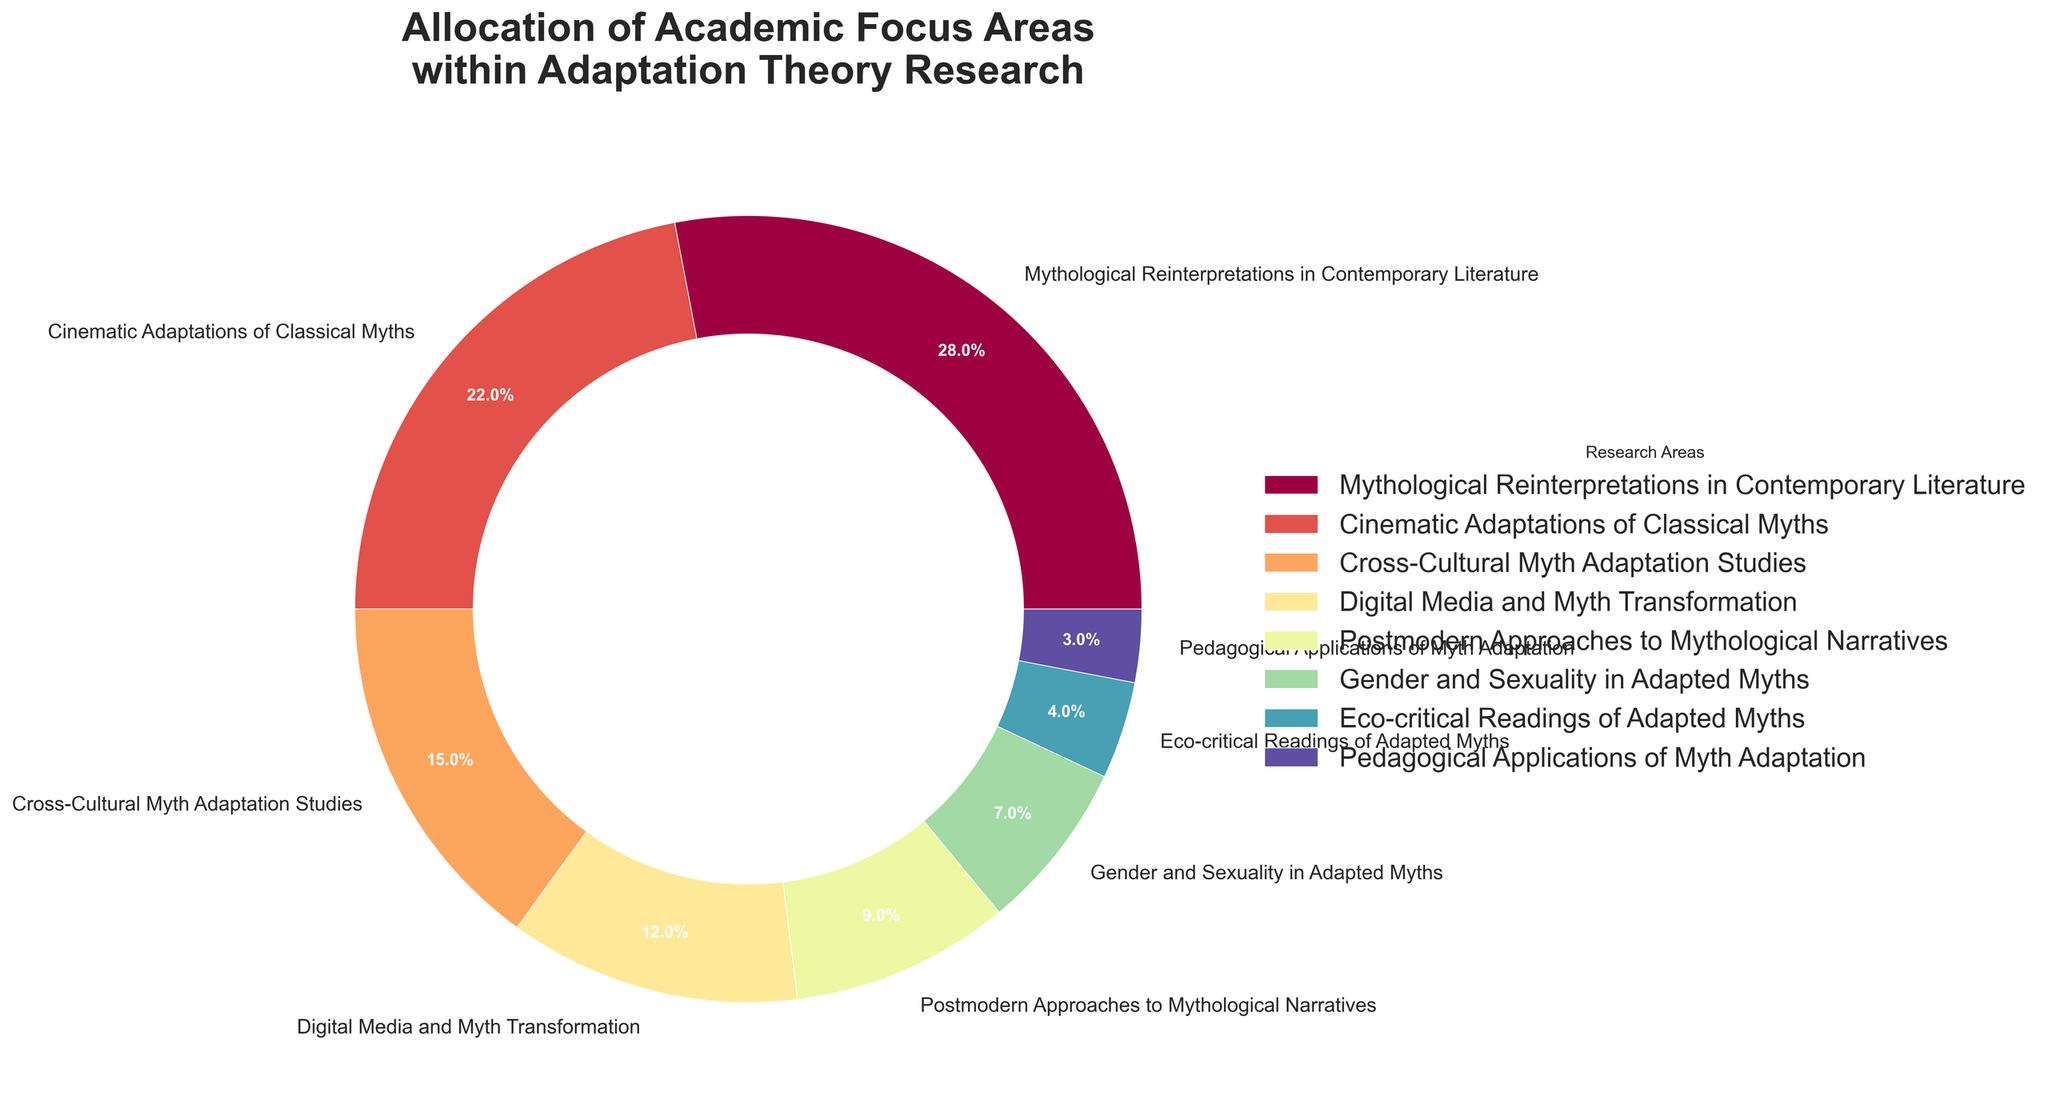What's the most researched area in this pie chart? To find the most researched area, look for the segment with the largest percentage. The "Mythological Reinterpretations in Contemporary Literature" segment has the largest size, which is 28%.
Answer: Mythological Reinterpretations in Contemporary Literature How does the percentage allocated to "Cinematic Adaptations of Classical Myths" compare to "Digital Media and Myth Transformation"? Compare the percentages for both areas. "Cinematic Adaptations of Classical Myths" is 22%, and "Digital Media and Myth Transformation" is 12%. 22% is greater than 12%.
Answer: "Cinematic Adaptations of Classical Myths" is greater What is the combined percentage of "Cross-Cultural Myth Adaptation Studies" and "Postmodern Approaches to Mythological Narratives"? Add the percentages of "Cross-Cultural Myth Adaptation Studies" (15%) and "Postmodern Approaches to Mythological Narratives" (9%). 15% + 9% = 24%.
Answer: 24% Which area has the smallest focus, and what is its percentage? To identify the smallest area, look for the segment with the lowest percentage. "Pedagogical Applications of Myth Adaptation" has the smallest segment at 3%.
Answer: Pedagogical Applications of Myth Adaptation, 3% What is the difference between the focus on "Gender and Sexuality in Adapted Myths" and "Eco-critical Readings of Adapted Myths"? Subtract the percentage of "Eco-critical Readings of Adapted Myths" (4%) from "Gender and Sexuality in Adapted Myths" (7%). 7% - 4% = 3%.
Answer: 3% How do the focuses on "Mythological Reinterpretations in Contemporary Literature" and "Cinematic Adaptations of Classical Myths" together compare to the sum of all other focus areas? First, add the percentages of "Mythological Reinterpretations in Contemporary Literature" (28%) and "Cinematic Adaptations of Classical Myths" (22%) together: 28% + 22% = 50%. Then sum all the other percentages: 15% + 12% + 9% + 7% + 4% + 3% = 50%. Both sums are equal at 50%.
Answer: They are equal What is the average percentage of the four areas with the lowest focus percentages? Find the four areas with the lowest focus percentages: "Digital Media and Myth Transformation" (12%), "Postmodern Approaches to Mythological Narratives" (9%), "Gender and Sexuality in Adapted Myths" (7%), "Eco-critical Readings of Adapted Myths" (4%), "Pedagogical Applications of Myth Adaptation" (3%). Add their percentages: 12% + 9% + 7% + 4% + 3% = 35%. Divide by the number of areas, which is 4. Average = 35% / 4 = 8.75%.
Answer: 8.75% How many research areas have more than a 10% allocation? Identify all areas with more than a 10% allocation: "Mythological Reinterpretations in Contemporary Literature" (28%), "Cinematic Adaptations of Classical Myths" (22%), and "Cross-Cultural Myth Adaptation Studies" (15%). These are 3 areas.
Answer: 3 What's the sum of the percentages for "Cinematic Adaptations of Classical Myths", "Gender and Sexuality in Adapted Myths", and "Pedagogical Applications of Myth Adaptation"? Add the percentages for the three areas: "Cinematic Adaptations of Classical Myths" (22%) + "Gender and Sexuality in Adapted Myths" (7%) + "Pedagogical Applications of Myth Adaptation" (3%). 22% + 7% + 3% = 32%.
Answer: 32% 